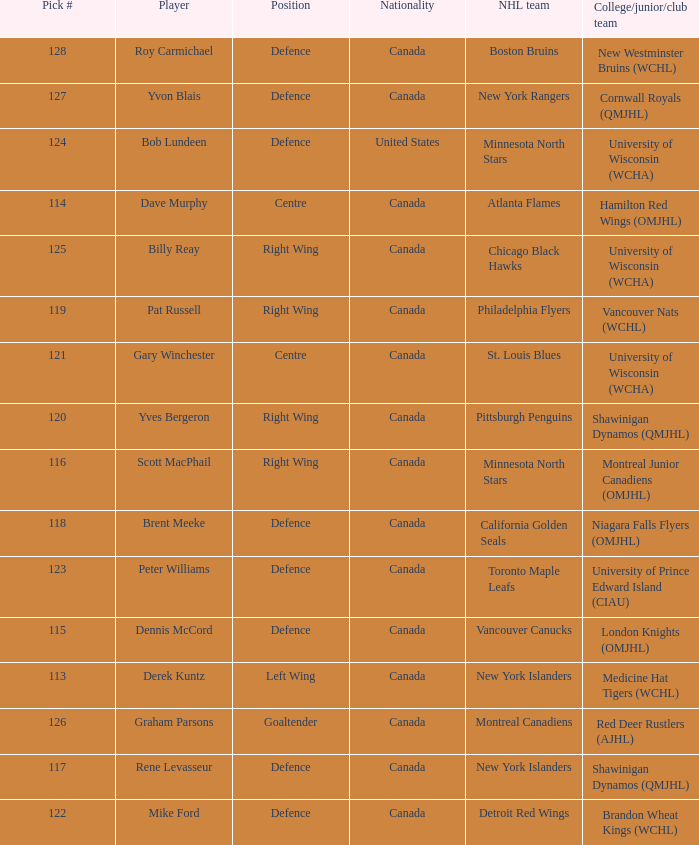Name the position for pick number 128 Defence. 